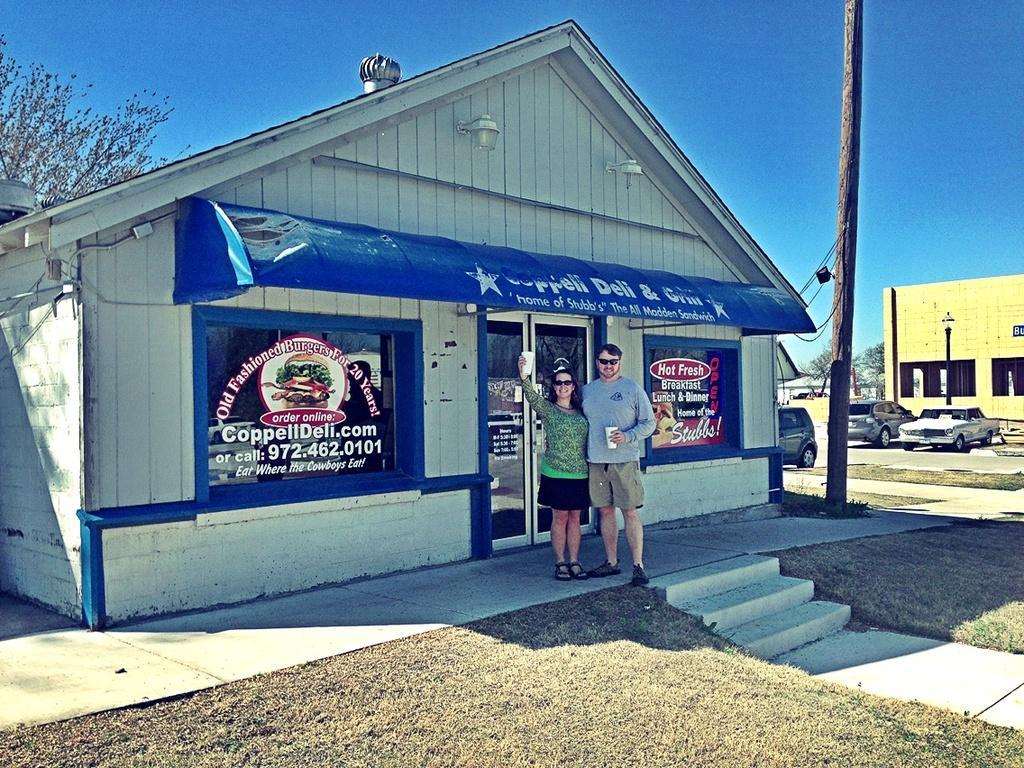Could you give a brief overview of what you see in this image? In this picture we can see a man and a woman standing on the floor and smiling, buildings, cars on the ground, trees, steps and in the background we can see the sky. 